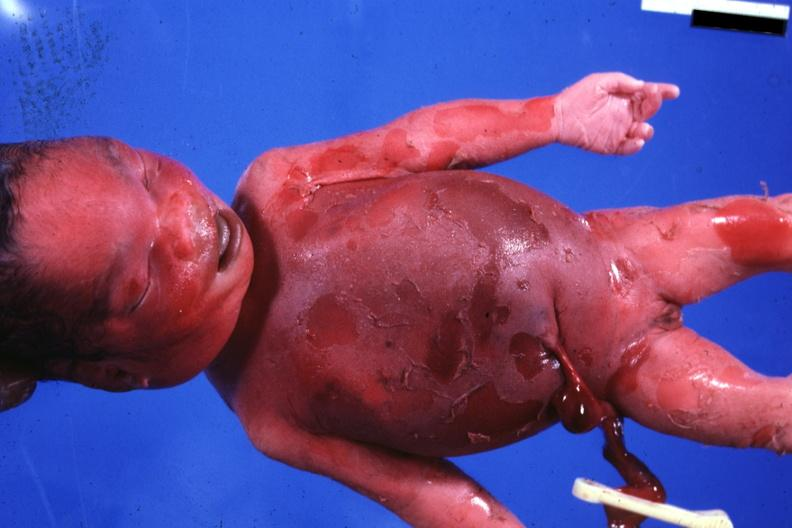does this image show typical appearance 980gm?
Answer the question using a single word or phrase. Yes 